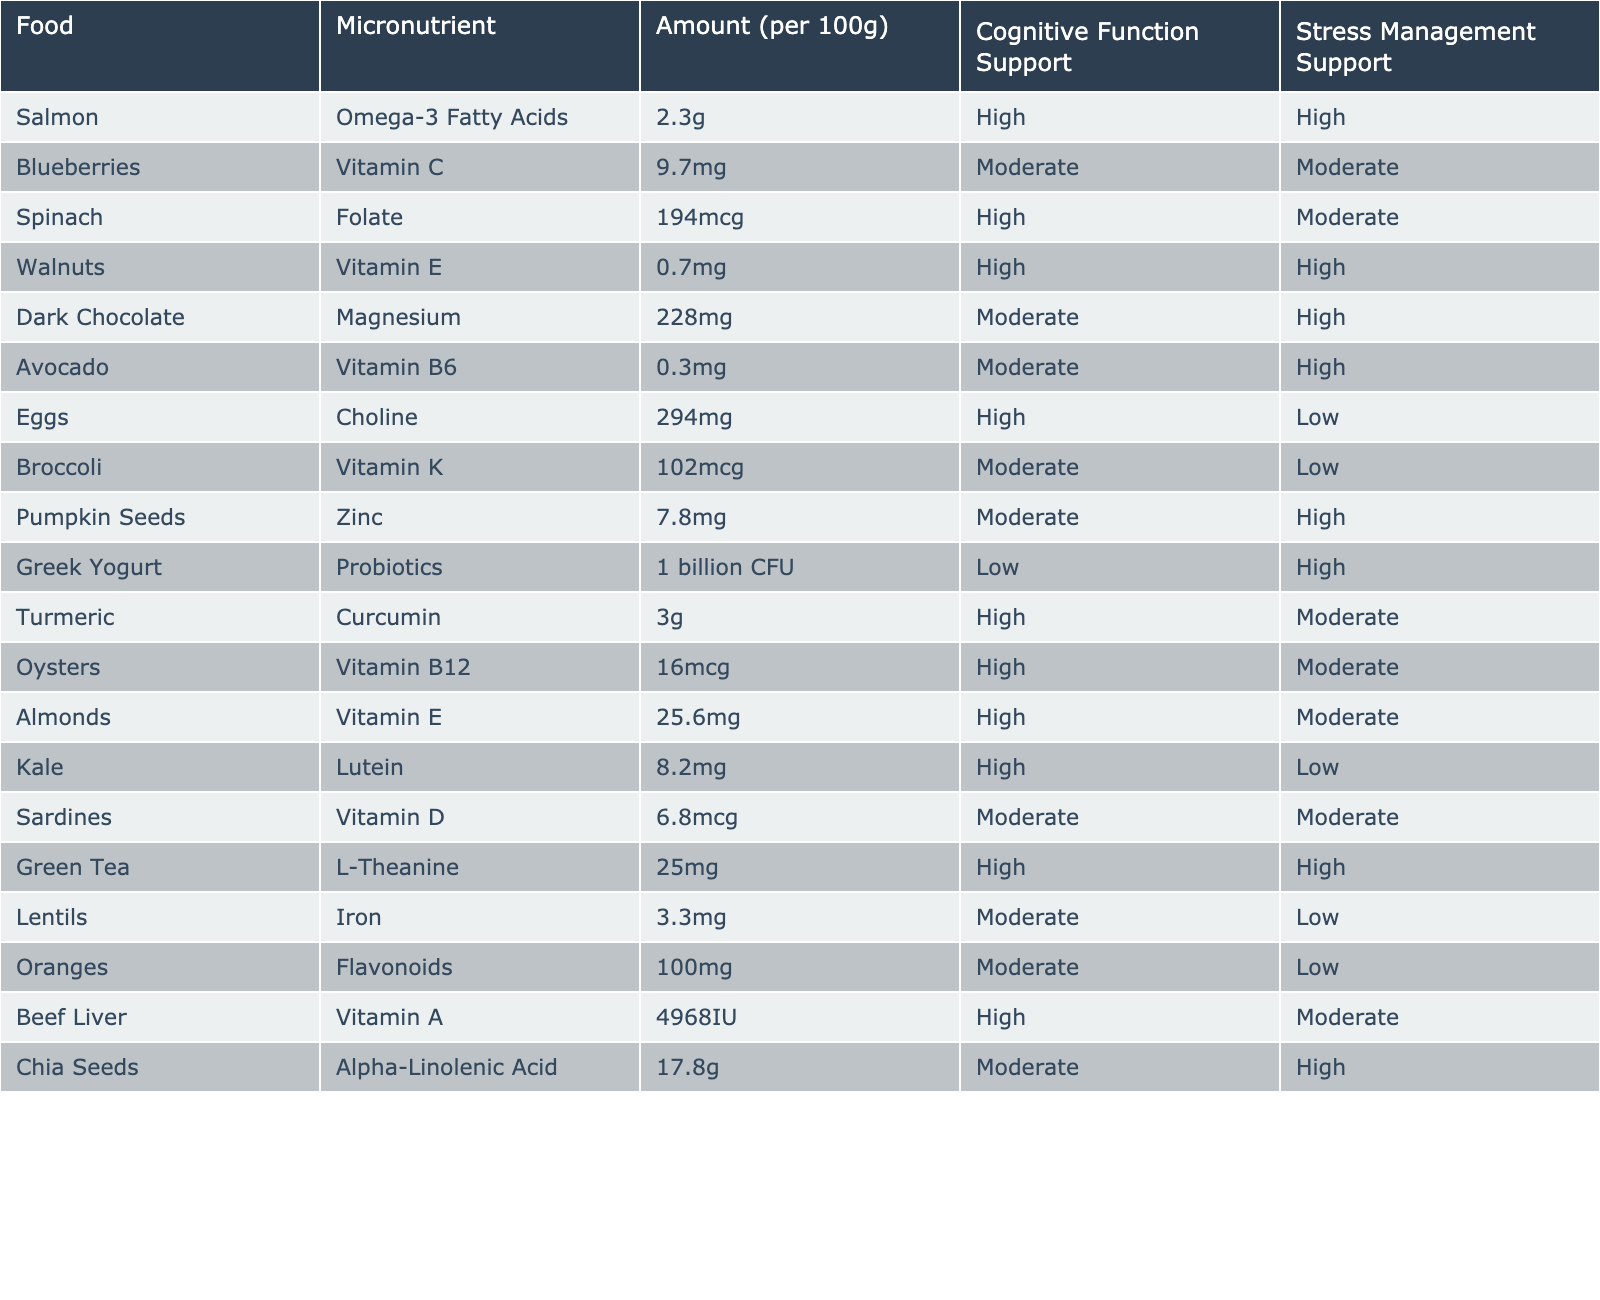What is the amount of Vitamin C in Blueberries? The table shows that Blueberries contain 9.7mg of Vitamin C per 100g.
Answer: 9.7mg Which food has the highest amount of Vitamin A? The table indicates that Beef Liver has 4968 IU of Vitamin A per 100g, which is higher than any other food listed.
Answer: Beef Liver Do Eggs provide high support for stress management? The table states that Eggs have a low support rating for stress management.
Answer: No Which food supports both cognitive function and stress management at a high level? Salmon and Walnuts are marked as "High" support for both cognitive function and stress management in the table.
Answer: Salmon and Walnuts How many foods in the table have "Moderate" support for cognitive function? By examining the table, the foods with "Moderate" support for cognitive function are Blueberries, Dark Chocolate, Avocado, Broccoli, Sardines, and Chia Seeds. There are 6 such foods.
Answer: 6 Is there any food listed that provides probiotics? The table lists Greek Yogurt as containing Probiotics, confirming that there is food that provides probiotics.
Answer: Yes What is the total amount of Omega-3 Fatty Acids in Salmon and Chia Seeds combined? The table states that Salmon contains 2.3g and Chia Seeds contain 17.8g of Omega-3 Fatty Acids. Adding these gives: 2.3g + 17.8g = 20.1g.
Answer: 20.1g Which micronutrient is found in Dark Chocolate, and how does it rank for stress management? The table shows that Dark Chocolate contains Magnesium and has a "High" rating for stress management support.
Answer: Magnesium, High Which food has the least amount of micronutrient support for cognitive function? Looking at the table, Greek Yogurt is marked as "Low" for cognitive function support, making it the least supportive.
Answer: Greek Yogurt If you want to maximize both cognitive function and stress management support, which food combinations should you choose? The foods with high support for both categories are Salmon, Walnuts, and Green Tea, which would be the best combinations for maximizing both supports.
Answer: Salmon, Walnuts, Green Tea 